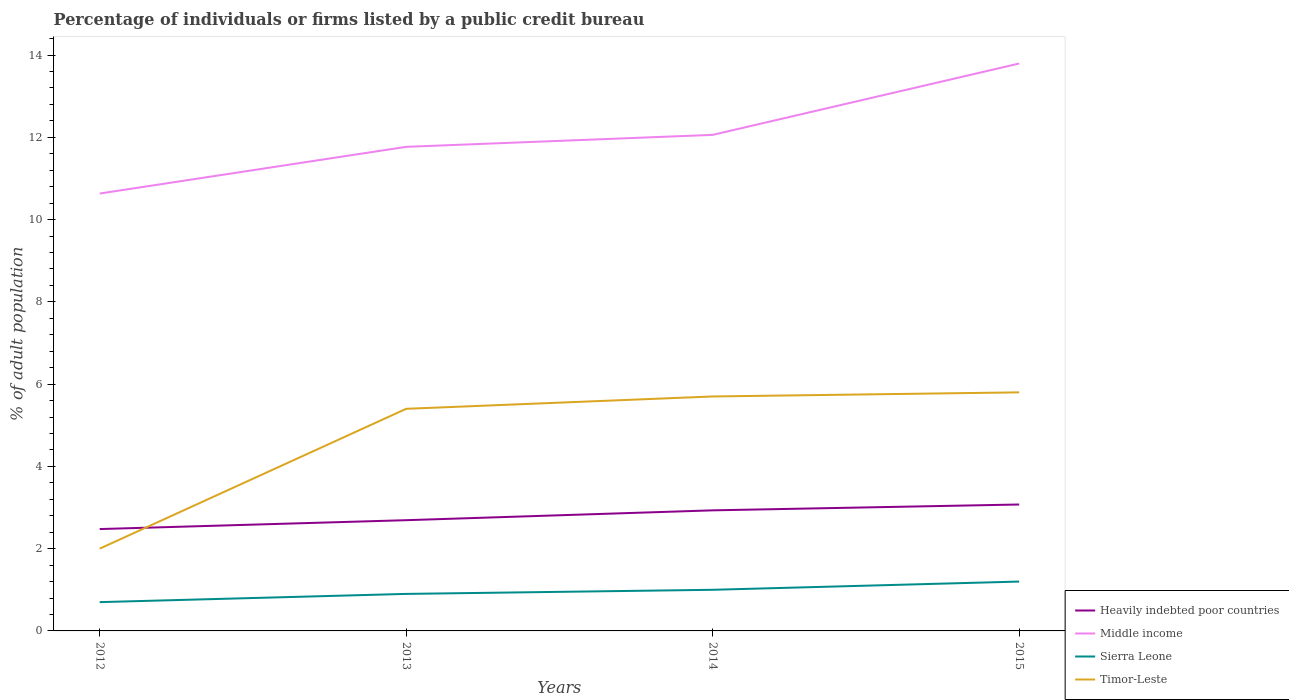How many different coloured lines are there?
Make the answer very short. 4. Does the line corresponding to Heavily indebted poor countries intersect with the line corresponding to Timor-Leste?
Provide a short and direct response. Yes. Is the number of lines equal to the number of legend labels?
Ensure brevity in your answer.  Yes. Across all years, what is the maximum percentage of population listed by a public credit bureau in Timor-Leste?
Provide a short and direct response. 2. What is the total percentage of population listed by a public credit bureau in Middle income in the graph?
Provide a succinct answer. -1.14. What is the difference between the highest and the second highest percentage of population listed by a public credit bureau in Heavily indebted poor countries?
Your answer should be compact. 0.6. What is the difference between the highest and the lowest percentage of population listed by a public credit bureau in Middle income?
Provide a succinct answer. 1. How many lines are there?
Your response must be concise. 4. How many years are there in the graph?
Provide a succinct answer. 4. Does the graph contain any zero values?
Offer a terse response. No. Does the graph contain grids?
Offer a very short reply. No. What is the title of the graph?
Ensure brevity in your answer.  Percentage of individuals or firms listed by a public credit bureau. Does "Turkmenistan" appear as one of the legend labels in the graph?
Keep it short and to the point. No. What is the label or title of the Y-axis?
Ensure brevity in your answer.  % of adult population. What is the % of adult population in Heavily indebted poor countries in 2012?
Your answer should be very brief. 2.48. What is the % of adult population of Middle income in 2012?
Provide a succinct answer. 10.63. What is the % of adult population in Sierra Leone in 2012?
Keep it short and to the point. 0.7. What is the % of adult population of Timor-Leste in 2012?
Your answer should be compact. 2. What is the % of adult population of Heavily indebted poor countries in 2013?
Provide a succinct answer. 2.69. What is the % of adult population in Middle income in 2013?
Provide a short and direct response. 11.77. What is the % of adult population of Heavily indebted poor countries in 2014?
Your response must be concise. 2.93. What is the % of adult population of Middle income in 2014?
Your answer should be compact. 12.06. What is the % of adult population in Sierra Leone in 2014?
Offer a very short reply. 1. What is the % of adult population in Heavily indebted poor countries in 2015?
Make the answer very short. 3.07. What is the % of adult population of Middle income in 2015?
Your answer should be very brief. 13.79. What is the % of adult population in Sierra Leone in 2015?
Offer a terse response. 1.2. What is the % of adult population in Timor-Leste in 2015?
Make the answer very short. 5.8. Across all years, what is the maximum % of adult population of Heavily indebted poor countries?
Ensure brevity in your answer.  3.07. Across all years, what is the maximum % of adult population of Middle income?
Keep it short and to the point. 13.79. Across all years, what is the maximum % of adult population of Sierra Leone?
Provide a short and direct response. 1.2. Across all years, what is the maximum % of adult population of Timor-Leste?
Keep it short and to the point. 5.8. Across all years, what is the minimum % of adult population of Heavily indebted poor countries?
Offer a very short reply. 2.48. Across all years, what is the minimum % of adult population in Middle income?
Provide a short and direct response. 10.63. Across all years, what is the minimum % of adult population of Timor-Leste?
Offer a very short reply. 2. What is the total % of adult population of Heavily indebted poor countries in the graph?
Offer a very short reply. 11.17. What is the total % of adult population in Middle income in the graph?
Keep it short and to the point. 48.26. What is the total % of adult population of Timor-Leste in the graph?
Ensure brevity in your answer.  18.9. What is the difference between the % of adult population in Heavily indebted poor countries in 2012 and that in 2013?
Make the answer very short. -0.22. What is the difference between the % of adult population of Middle income in 2012 and that in 2013?
Your answer should be compact. -1.14. What is the difference between the % of adult population in Heavily indebted poor countries in 2012 and that in 2014?
Give a very brief answer. -0.46. What is the difference between the % of adult population in Middle income in 2012 and that in 2014?
Offer a very short reply. -1.43. What is the difference between the % of adult population of Timor-Leste in 2012 and that in 2014?
Your answer should be compact. -3.7. What is the difference between the % of adult population of Heavily indebted poor countries in 2012 and that in 2015?
Keep it short and to the point. -0.6. What is the difference between the % of adult population in Middle income in 2012 and that in 2015?
Offer a very short reply. -3.16. What is the difference between the % of adult population of Sierra Leone in 2012 and that in 2015?
Offer a very short reply. -0.5. What is the difference between the % of adult population in Timor-Leste in 2012 and that in 2015?
Keep it short and to the point. -3.8. What is the difference between the % of adult population in Heavily indebted poor countries in 2013 and that in 2014?
Your response must be concise. -0.24. What is the difference between the % of adult population in Middle income in 2013 and that in 2014?
Offer a very short reply. -0.29. What is the difference between the % of adult population in Sierra Leone in 2013 and that in 2014?
Ensure brevity in your answer.  -0.1. What is the difference between the % of adult population of Timor-Leste in 2013 and that in 2014?
Ensure brevity in your answer.  -0.3. What is the difference between the % of adult population in Heavily indebted poor countries in 2013 and that in 2015?
Offer a terse response. -0.38. What is the difference between the % of adult population of Middle income in 2013 and that in 2015?
Make the answer very short. -2.03. What is the difference between the % of adult population of Sierra Leone in 2013 and that in 2015?
Ensure brevity in your answer.  -0.3. What is the difference between the % of adult population of Heavily indebted poor countries in 2014 and that in 2015?
Your answer should be very brief. -0.14. What is the difference between the % of adult population in Middle income in 2014 and that in 2015?
Your answer should be compact. -1.74. What is the difference between the % of adult population of Sierra Leone in 2014 and that in 2015?
Give a very brief answer. -0.2. What is the difference between the % of adult population in Timor-Leste in 2014 and that in 2015?
Give a very brief answer. -0.1. What is the difference between the % of adult population in Heavily indebted poor countries in 2012 and the % of adult population in Middle income in 2013?
Offer a terse response. -9.29. What is the difference between the % of adult population in Heavily indebted poor countries in 2012 and the % of adult population in Sierra Leone in 2013?
Make the answer very short. 1.58. What is the difference between the % of adult population of Heavily indebted poor countries in 2012 and the % of adult population of Timor-Leste in 2013?
Ensure brevity in your answer.  -2.92. What is the difference between the % of adult population of Middle income in 2012 and the % of adult population of Sierra Leone in 2013?
Provide a succinct answer. 9.73. What is the difference between the % of adult population of Middle income in 2012 and the % of adult population of Timor-Leste in 2013?
Your answer should be very brief. 5.23. What is the difference between the % of adult population in Sierra Leone in 2012 and the % of adult population in Timor-Leste in 2013?
Give a very brief answer. -4.7. What is the difference between the % of adult population in Heavily indebted poor countries in 2012 and the % of adult population in Middle income in 2014?
Your answer should be compact. -9.58. What is the difference between the % of adult population in Heavily indebted poor countries in 2012 and the % of adult population in Sierra Leone in 2014?
Offer a terse response. 1.48. What is the difference between the % of adult population of Heavily indebted poor countries in 2012 and the % of adult population of Timor-Leste in 2014?
Offer a terse response. -3.22. What is the difference between the % of adult population of Middle income in 2012 and the % of adult population of Sierra Leone in 2014?
Your answer should be very brief. 9.63. What is the difference between the % of adult population of Middle income in 2012 and the % of adult population of Timor-Leste in 2014?
Give a very brief answer. 4.93. What is the difference between the % of adult population of Sierra Leone in 2012 and the % of adult population of Timor-Leste in 2014?
Your answer should be very brief. -5. What is the difference between the % of adult population in Heavily indebted poor countries in 2012 and the % of adult population in Middle income in 2015?
Offer a terse response. -11.32. What is the difference between the % of adult population in Heavily indebted poor countries in 2012 and the % of adult population in Sierra Leone in 2015?
Keep it short and to the point. 1.28. What is the difference between the % of adult population of Heavily indebted poor countries in 2012 and the % of adult population of Timor-Leste in 2015?
Ensure brevity in your answer.  -3.32. What is the difference between the % of adult population in Middle income in 2012 and the % of adult population in Sierra Leone in 2015?
Your answer should be very brief. 9.43. What is the difference between the % of adult population of Middle income in 2012 and the % of adult population of Timor-Leste in 2015?
Your answer should be very brief. 4.83. What is the difference between the % of adult population in Heavily indebted poor countries in 2013 and the % of adult population in Middle income in 2014?
Your response must be concise. -9.37. What is the difference between the % of adult population of Heavily indebted poor countries in 2013 and the % of adult population of Sierra Leone in 2014?
Your answer should be compact. 1.69. What is the difference between the % of adult population in Heavily indebted poor countries in 2013 and the % of adult population in Timor-Leste in 2014?
Your answer should be compact. -3.01. What is the difference between the % of adult population in Middle income in 2013 and the % of adult population in Sierra Leone in 2014?
Your answer should be compact. 10.77. What is the difference between the % of adult population in Middle income in 2013 and the % of adult population in Timor-Leste in 2014?
Offer a terse response. 6.07. What is the difference between the % of adult population of Heavily indebted poor countries in 2013 and the % of adult population of Middle income in 2015?
Give a very brief answer. -11.1. What is the difference between the % of adult population of Heavily indebted poor countries in 2013 and the % of adult population of Sierra Leone in 2015?
Your answer should be very brief. 1.49. What is the difference between the % of adult population of Heavily indebted poor countries in 2013 and the % of adult population of Timor-Leste in 2015?
Give a very brief answer. -3.11. What is the difference between the % of adult population in Middle income in 2013 and the % of adult population in Sierra Leone in 2015?
Provide a succinct answer. 10.57. What is the difference between the % of adult population of Middle income in 2013 and the % of adult population of Timor-Leste in 2015?
Your answer should be compact. 5.97. What is the difference between the % of adult population in Heavily indebted poor countries in 2014 and the % of adult population in Middle income in 2015?
Ensure brevity in your answer.  -10.86. What is the difference between the % of adult population in Heavily indebted poor countries in 2014 and the % of adult population in Sierra Leone in 2015?
Your answer should be compact. 1.73. What is the difference between the % of adult population in Heavily indebted poor countries in 2014 and the % of adult population in Timor-Leste in 2015?
Your answer should be very brief. -2.87. What is the difference between the % of adult population in Middle income in 2014 and the % of adult population in Sierra Leone in 2015?
Give a very brief answer. 10.86. What is the difference between the % of adult population of Middle income in 2014 and the % of adult population of Timor-Leste in 2015?
Your response must be concise. 6.26. What is the difference between the % of adult population in Sierra Leone in 2014 and the % of adult population in Timor-Leste in 2015?
Your answer should be very brief. -4.8. What is the average % of adult population in Heavily indebted poor countries per year?
Provide a short and direct response. 2.79. What is the average % of adult population in Middle income per year?
Your answer should be compact. 12.06. What is the average % of adult population in Timor-Leste per year?
Keep it short and to the point. 4.72. In the year 2012, what is the difference between the % of adult population of Heavily indebted poor countries and % of adult population of Middle income?
Make the answer very short. -8.16. In the year 2012, what is the difference between the % of adult population in Heavily indebted poor countries and % of adult population in Sierra Leone?
Your response must be concise. 1.78. In the year 2012, what is the difference between the % of adult population of Heavily indebted poor countries and % of adult population of Timor-Leste?
Ensure brevity in your answer.  0.48. In the year 2012, what is the difference between the % of adult population of Middle income and % of adult population of Sierra Leone?
Your answer should be compact. 9.93. In the year 2012, what is the difference between the % of adult population of Middle income and % of adult population of Timor-Leste?
Your answer should be very brief. 8.63. In the year 2012, what is the difference between the % of adult population of Sierra Leone and % of adult population of Timor-Leste?
Provide a succinct answer. -1.3. In the year 2013, what is the difference between the % of adult population in Heavily indebted poor countries and % of adult population in Middle income?
Keep it short and to the point. -9.08. In the year 2013, what is the difference between the % of adult population of Heavily indebted poor countries and % of adult population of Sierra Leone?
Your answer should be very brief. 1.79. In the year 2013, what is the difference between the % of adult population in Heavily indebted poor countries and % of adult population in Timor-Leste?
Provide a succinct answer. -2.71. In the year 2013, what is the difference between the % of adult population of Middle income and % of adult population of Sierra Leone?
Ensure brevity in your answer.  10.87. In the year 2013, what is the difference between the % of adult population in Middle income and % of adult population in Timor-Leste?
Ensure brevity in your answer.  6.37. In the year 2014, what is the difference between the % of adult population in Heavily indebted poor countries and % of adult population in Middle income?
Provide a succinct answer. -9.13. In the year 2014, what is the difference between the % of adult population in Heavily indebted poor countries and % of adult population in Sierra Leone?
Your response must be concise. 1.93. In the year 2014, what is the difference between the % of adult population in Heavily indebted poor countries and % of adult population in Timor-Leste?
Make the answer very short. -2.77. In the year 2014, what is the difference between the % of adult population of Middle income and % of adult population of Sierra Leone?
Provide a succinct answer. 11.06. In the year 2014, what is the difference between the % of adult population in Middle income and % of adult population in Timor-Leste?
Offer a terse response. 6.36. In the year 2015, what is the difference between the % of adult population in Heavily indebted poor countries and % of adult population in Middle income?
Make the answer very short. -10.72. In the year 2015, what is the difference between the % of adult population of Heavily indebted poor countries and % of adult population of Sierra Leone?
Your answer should be very brief. 1.87. In the year 2015, what is the difference between the % of adult population in Heavily indebted poor countries and % of adult population in Timor-Leste?
Your response must be concise. -2.73. In the year 2015, what is the difference between the % of adult population of Middle income and % of adult population of Sierra Leone?
Give a very brief answer. 12.6. In the year 2015, what is the difference between the % of adult population in Middle income and % of adult population in Timor-Leste?
Give a very brief answer. 8. What is the ratio of the % of adult population in Heavily indebted poor countries in 2012 to that in 2013?
Offer a very short reply. 0.92. What is the ratio of the % of adult population in Middle income in 2012 to that in 2013?
Your answer should be very brief. 0.9. What is the ratio of the % of adult population in Sierra Leone in 2012 to that in 2013?
Ensure brevity in your answer.  0.78. What is the ratio of the % of adult population in Timor-Leste in 2012 to that in 2013?
Offer a very short reply. 0.37. What is the ratio of the % of adult population in Heavily indebted poor countries in 2012 to that in 2014?
Make the answer very short. 0.84. What is the ratio of the % of adult population of Middle income in 2012 to that in 2014?
Give a very brief answer. 0.88. What is the ratio of the % of adult population of Timor-Leste in 2012 to that in 2014?
Provide a succinct answer. 0.35. What is the ratio of the % of adult population in Heavily indebted poor countries in 2012 to that in 2015?
Provide a short and direct response. 0.81. What is the ratio of the % of adult population in Middle income in 2012 to that in 2015?
Offer a terse response. 0.77. What is the ratio of the % of adult population in Sierra Leone in 2012 to that in 2015?
Offer a terse response. 0.58. What is the ratio of the % of adult population of Timor-Leste in 2012 to that in 2015?
Offer a very short reply. 0.34. What is the ratio of the % of adult population of Heavily indebted poor countries in 2013 to that in 2014?
Offer a very short reply. 0.92. What is the ratio of the % of adult population of Middle income in 2013 to that in 2014?
Offer a very short reply. 0.98. What is the ratio of the % of adult population of Sierra Leone in 2013 to that in 2014?
Ensure brevity in your answer.  0.9. What is the ratio of the % of adult population of Heavily indebted poor countries in 2013 to that in 2015?
Provide a succinct answer. 0.88. What is the ratio of the % of adult population of Middle income in 2013 to that in 2015?
Make the answer very short. 0.85. What is the ratio of the % of adult population in Sierra Leone in 2013 to that in 2015?
Ensure brevity in your answer.  0.75. What is the ratio of the % of adult population in Heavily indebted poor countries in 2014 to that in 2015?
Ensure brevity in your answer.  0.95. What is the ratio of the % of adult population in Middle income in 2014 to that in 2015?
Offer a terse response. 0.87. What is the ratio of the % of adult population in Sierra Leone in 2014 to that in 2015?
Ensure brevity in your answer.  0.83. What is the ratio of the % of adult population in Timor-Leste in 2014 to that in 2015?
Ensure brevity in your answer.  0.98. What is the difference between the highest and the second highest % of adult population of Heavily indebted poor countries?
Your response must be concise. 0.14. What is the difference between the highest and the second highest % of adult population in Middle income?
Your answer should be compact. 1.74. What is the difference between the highest and the second highest % of adult population in Sierra Leone?
Offer a terse response. 0.2. What is the difference between the highest and the second highest % of adult population in Timor-Leste?
Your answer should be compact. 0.1. What is the difference between the highest and the lowest % of adult population of Heavily indebted poor countries?
Ensure brevity in your answer.  0.6. What is the difference between the highest and the lowest % of adult population in Middle income?
Make the answer very short. 3.16. 